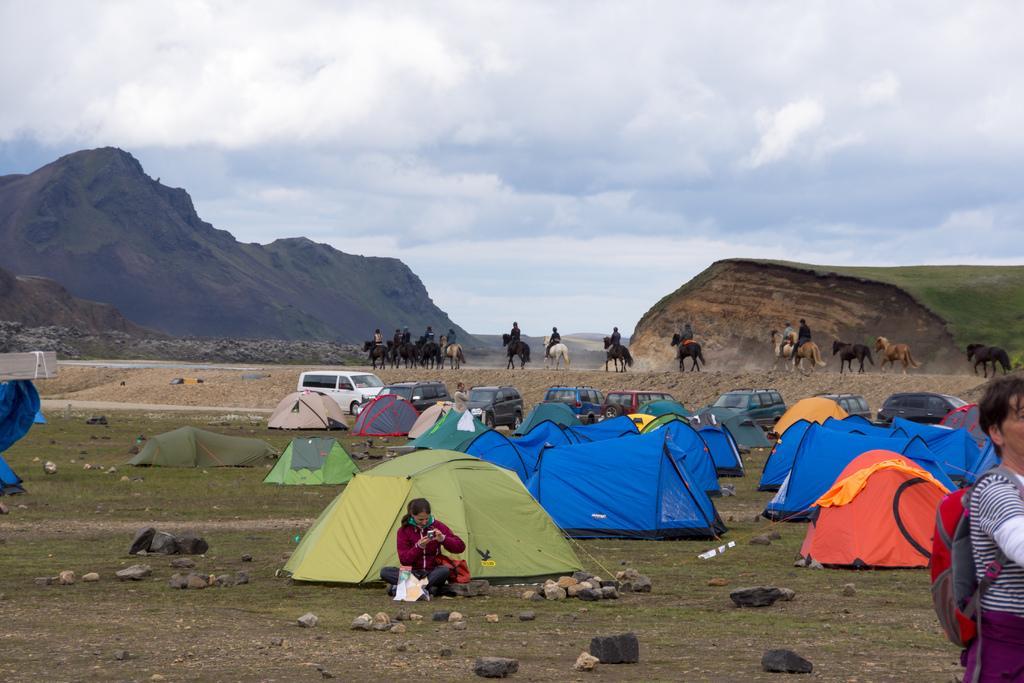Please provide a concise description of this image. In this image I can see few mountains, few camping-tents, stones and few people. I can see few people are sitting on the horses. The sky is in blue and white color. 